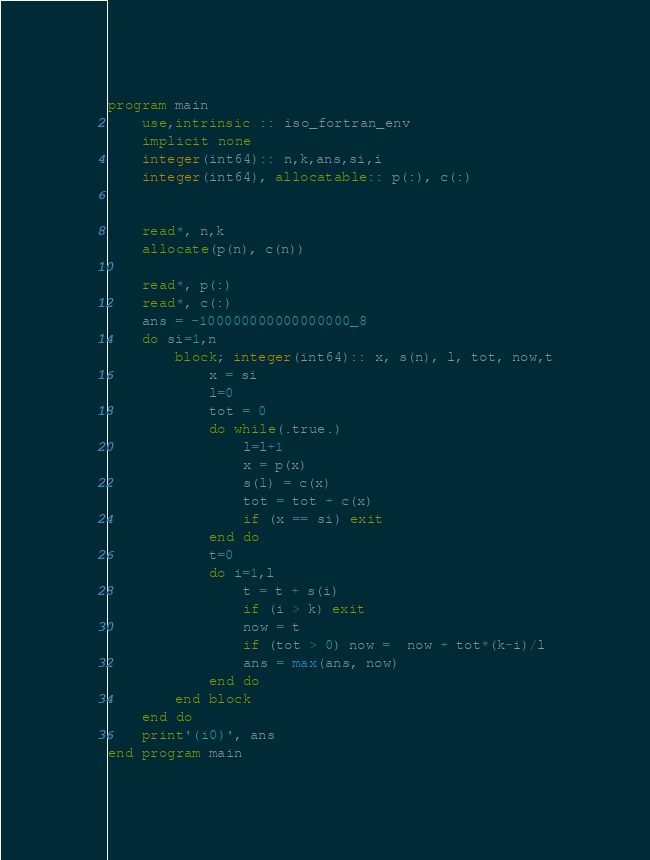<code> <loc_0><loc_0><loc_500><loc_500><_FORTRAN_>program main
    use,intrinsic :: iso_fortran_env
    implicit none
    integer(int64):: n,k,ans,si,i
    integer(int64), allocatable:: p(:), c(:)
        

    read*, n,k
    allocate(p(n), c(n))

    read*, p(:)
    read*, c(:)
    ans = -100000000000000000_8
    do si=1,n
        block; integer(int64):: x, s(n), l, tot, now,t
            x = si
            l=0
            tot = 0
            do while(.true.)
                l=l+1
                x = p(x)
                s(l) = c(x)
                tot = tot + c(x)
                if (x == si) exit
            end do
            t=0
            do i=1,l
                t = t + s(i)
                if (i > k) exit
                now = t
                if (tot > 0) now =  now + tot*(k-i)/l
                ans = max(ans, now)
            end do
        end block
    end do
    print'(i0)', ans
end program main</code> 